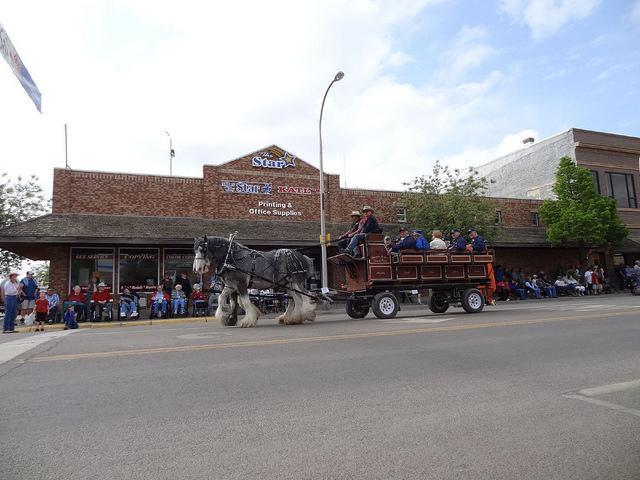What two factors are allowing the people to move?
Choose the right answer and clarify with the format: 'Answer: answer
Rationale: rationale.'
Options: Horse, driver, wheels, all correct. Answer: all correct.
Rationale: The wheels are allowing the people to move because without wheels the horses could not transport the large carriage filled with people. 